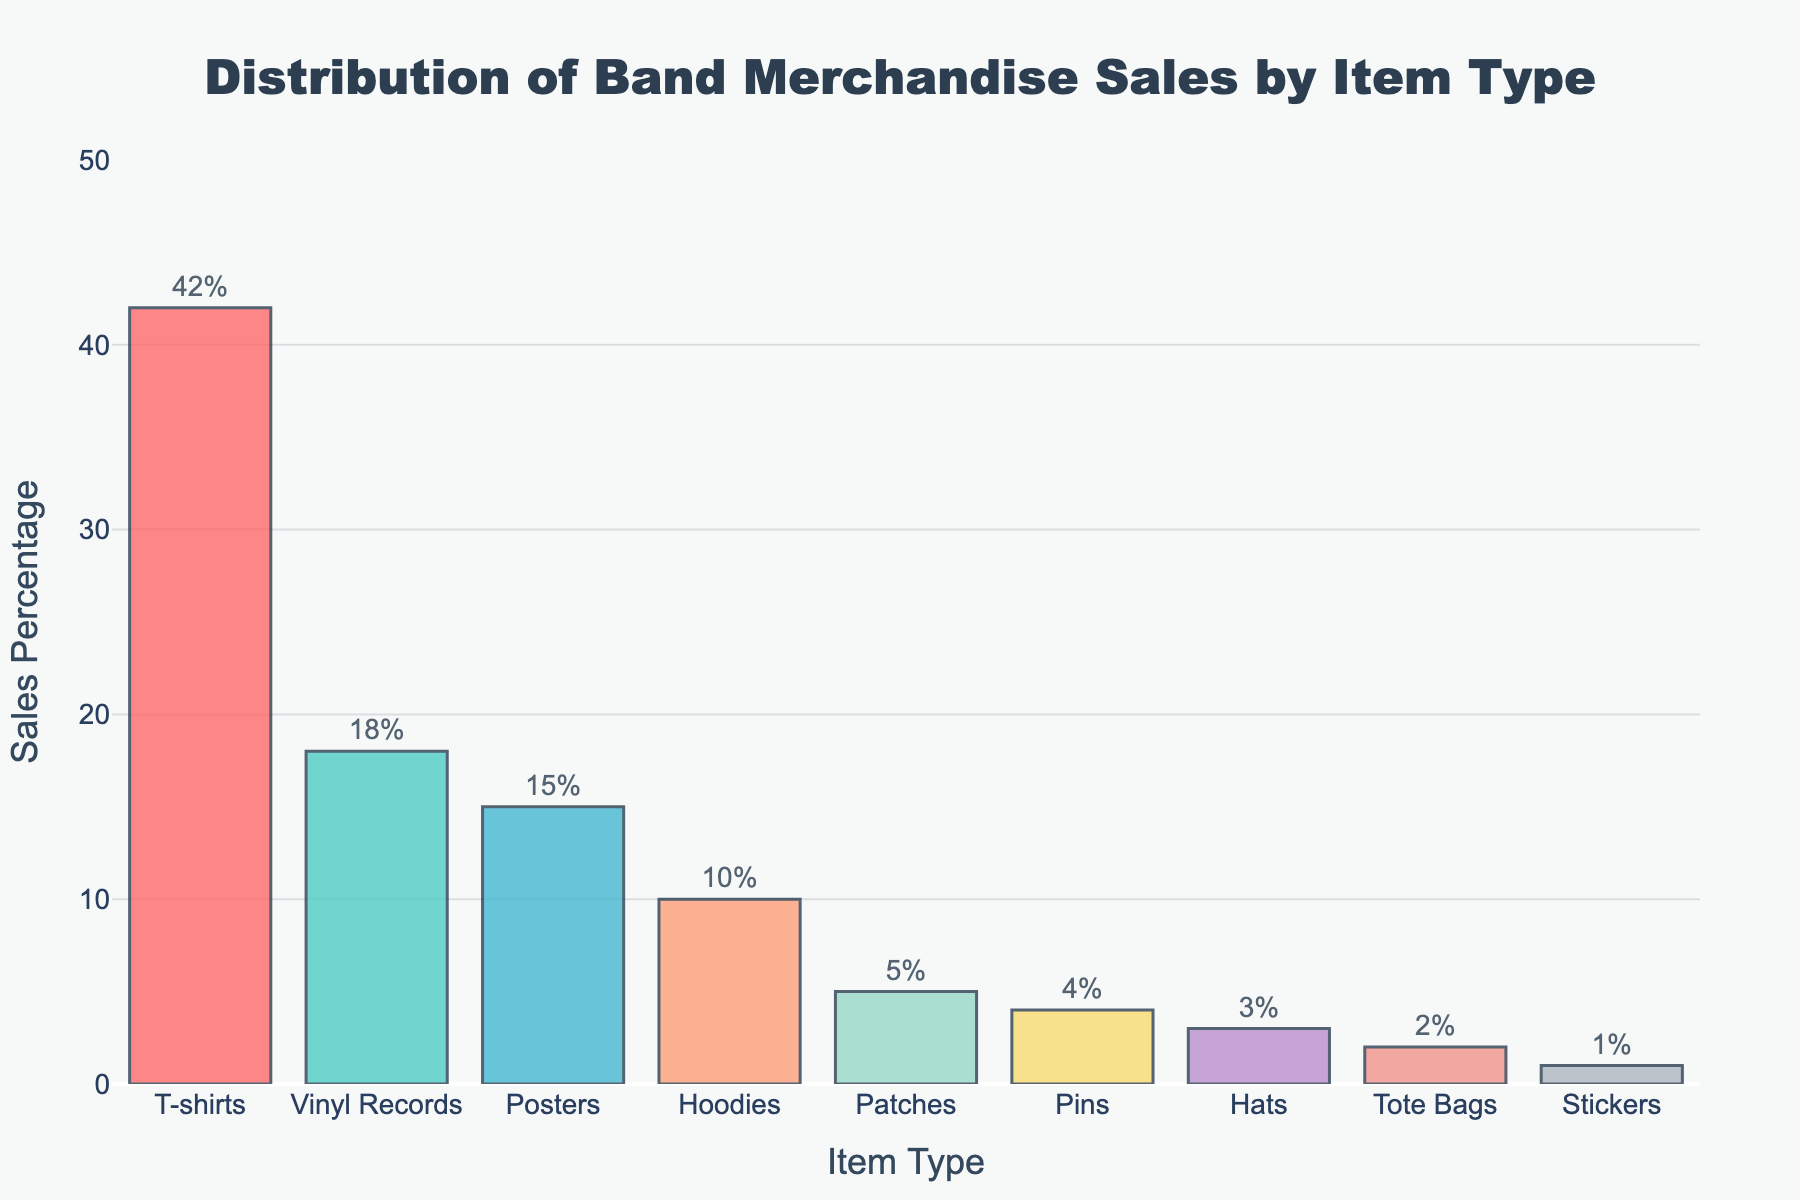What is the most popular item type in terms of sales percentage? The bar chart shows that "T-shirts" have the highest sales percentage, indicating that they are the most popular item type.
Answer: T-shirts Which item type contributes the least to the overall sales percentage? The bar corresponding to "Stickers" in the bar chart is the shortest, implying that they have the smallest sales percentage.
Answer: Stickers How much higher is the sales percentage for T-shirts compared to Posters? The sales percentage for T-shirts is 42% and for Posters it is 15%. Subtracting the two, 42 - 15 = 27%.
Answer: 27% What are the total sales percentages of Vinyl Records, Posters, and Hoodies combined? The sales percentages are: Vinyl Records (18%), Posters (15%), and Hoodies (10%). Adding them, 18 + 15 + 10 = 43%.
Answer: 43% Are the sales percentages for Hoodies and Patches combined greater than the sales percentage for Vinyl Records? The sales percentage for Hoodies is 10% and for Patches is 5%, which combined makes 15%. The sales percentage for Vinyl Records alone is 18%. Since 15% < 18%, the combined percentage is not greater.
Answer: No Which item types have sales percentages higher than 10%? By examining the chart, "T-shirts" (42%), "Vinyl Records" (18%), and "Posters" (15%) have sales percentages higher than 10%.
Answer: T-shirts, Vinyl Records, Posters How do the sales percentages for Patches and Pins compare? The sales percentage for Patches is 5% and for Pins is 4%. The sales percentage for Patches is higher than that for Pins by 1%.
Answer: Patches by 1% What's the cumulative percentage of the three least popular item types? The three least popular items are Hats (3%), Tote Bags (2%), and Stickers (1%). Adding them gives 3 + 2 + 1 = 6%.
Answer: 6% Which color is associated with the bars representing the item types with sales percentages of 42% and 18%? The bar for T-shirts (42%) is red, and the bar for Vinyl Records (18%) is teal.
Answer: Red, Teal 